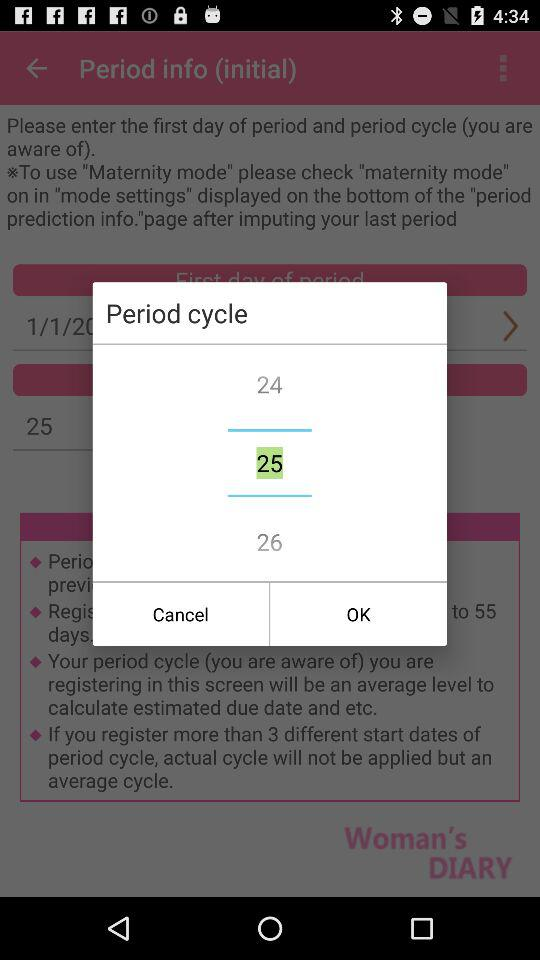What is the selected number of days in the period cycle? The selected number of days in the period cycle is 25. 